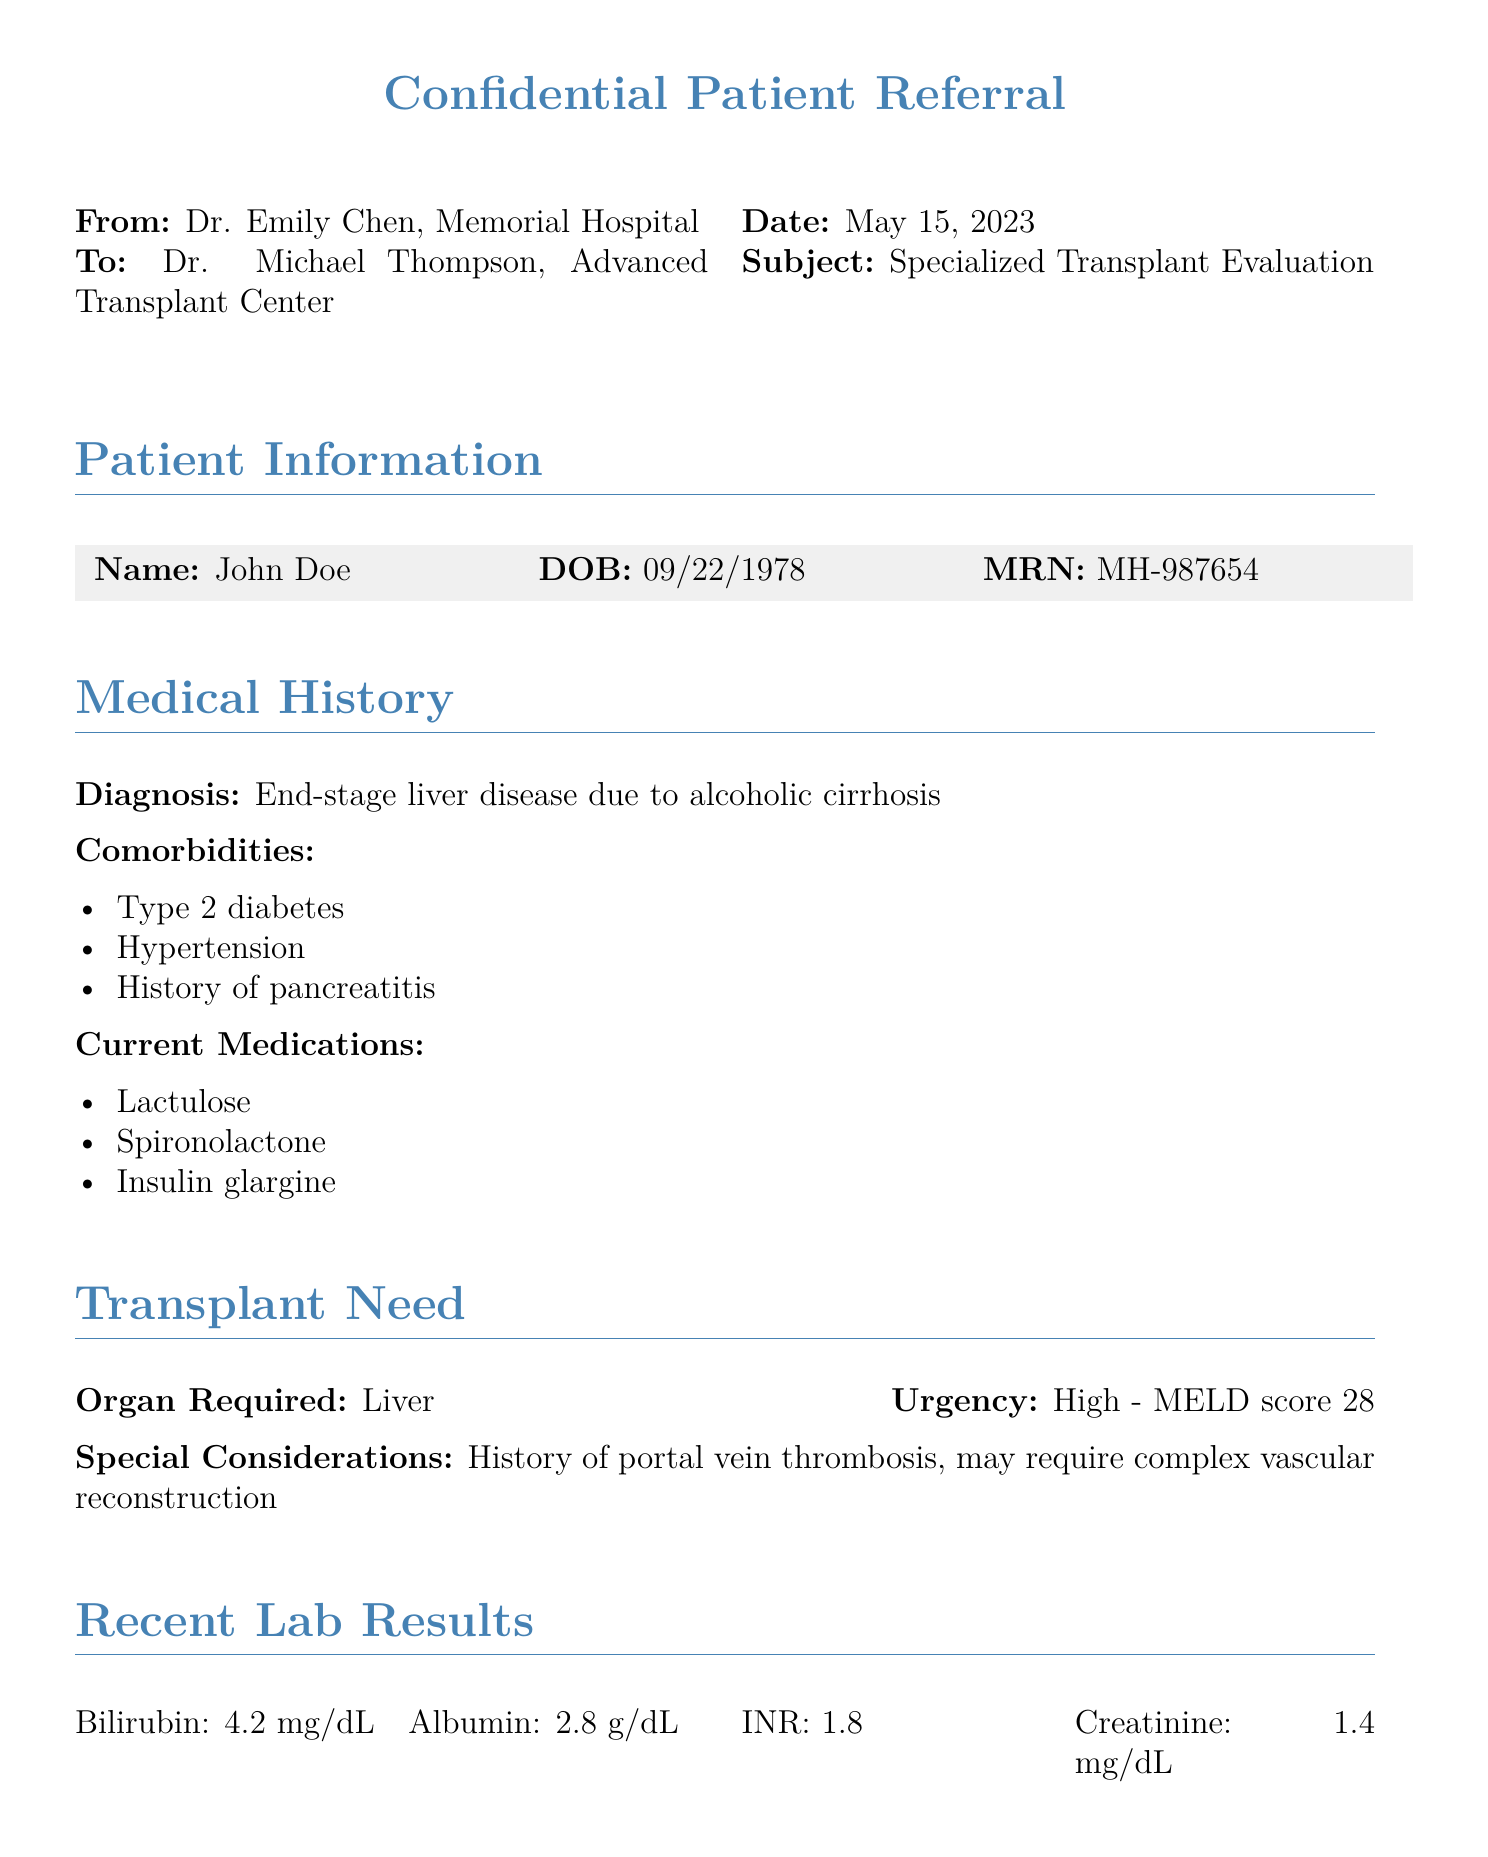what is the patient's name? The patient's name is listed under Patient Information in the document.
Answer: John Doe what is the patient's date of birth? The date of birth is specified in the same section as the patient's name.
Answer: 09/22/1978 what is the diagnosis mentioned in the medical history? The diagnosis is highlighted under the Medical History section of the document.
Answer: End-stage liver disease due to alcoholic cirrhosis what is the urgency level of the transplant needed? The urgency level is stated in the Transplant Need section regarding the urgency of the required organ.
Answer: High what is the MELD score provided for the patient? The MELD score is specifically mentioned in the Transplant Need section.
Answer: 28 how many comorbidities are listed for the patient? The number of comorbidities can be counted from the Medical History section where they are enumerated.
Answer: Three what is the contact email for the referring doctor? The doctor’s email is found in the Contact Information section at the end of the document.
Answer: e.chen@memorialhospital.org what is the main reason for the referral? The main reason for referral is outlined under the Reason for Referral section in the document.
Answer: Evaluation for potential living donor liver transplantation what imaging study was performed and when? The imaging study details are included under the Imaging Studies section with a specific date mentioned.
Answer: CT Abdomen (05/02/2023) what is noted about the patient's recent lab results? Recent lab results are summarized in a table; the answer can be derived from that table.
Answer: Bilirubin: 4.2 mg/dL 